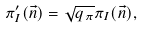Convert formula to latex. <formula><loc_0><loc_0><loc_500><loc_500>\pi _ { I } ^ { \prime } ( \vec { n } ) = \sqrt { q _ { \pi } } \pi _ { I } ( \vec { n } ) ,</formula> 